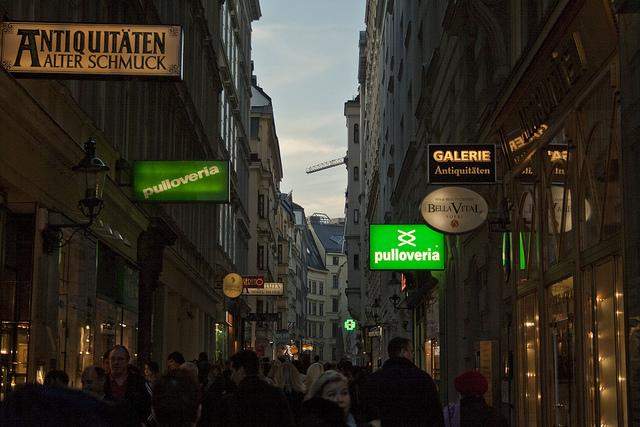Where is Pulloveria based? Please explain your reasoning. vienna. The shop has the origin in vienna. 